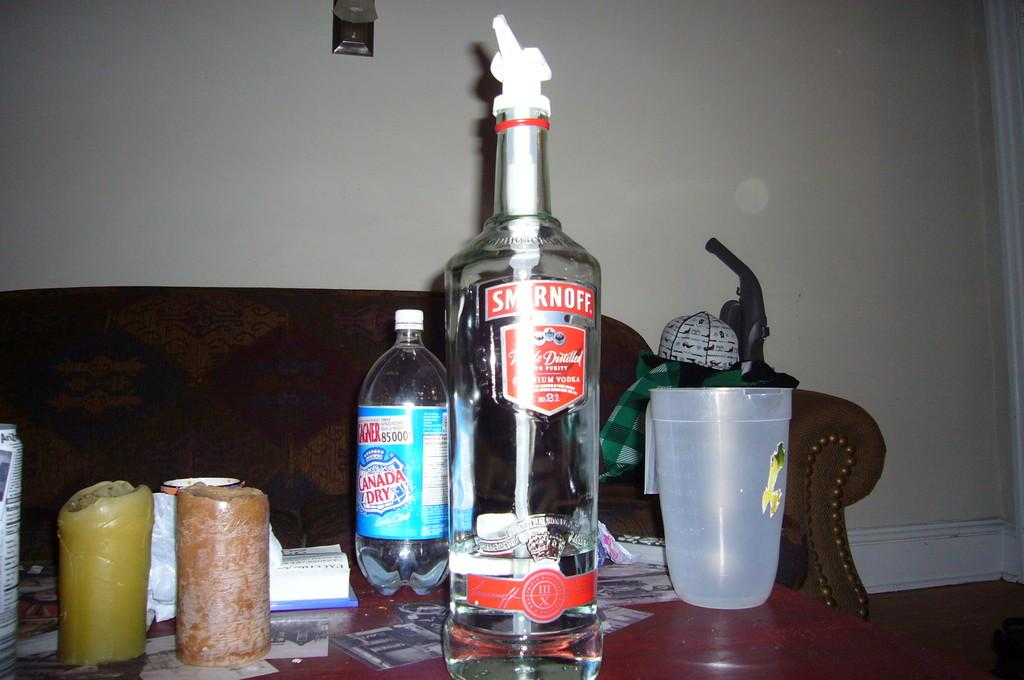<image>
Relay a brief, clear account of the picture shown. A bottle of Smirnoff on a coffee table is about one quater full. 